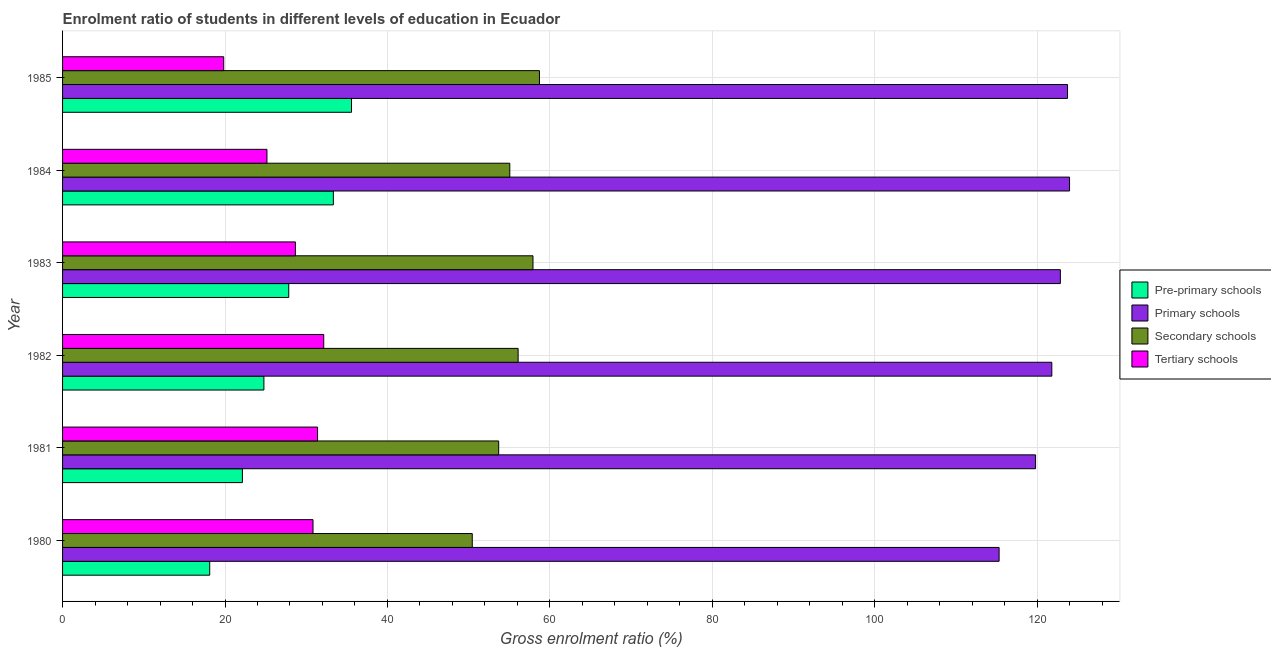How many different coloured bars are there?
Offer a very short reply. 4. Are the number of bars per tick equal to the number of legend labels?
Offer a very short reply. Yes. In how many cases, is the number of bars for a given year not equal to the number of legend labels?
Keep it short and to the point. 0. What is the gross enrolment ratio in tertiary schools in 1980?
Keep it short and to the point. 30.83. Across all years, what is the maximum gross enrolment ratio in primary schools?
Offer a very short reply. 123.98. Across all years, what is the minimum gross enrolment ratio in primary schools?
Your response must be concise. 115.31. What is the total gross enrolment ratio in secondary schools in the graph?
Keep it short and to the point. 331.92. What is the difference between the gross enrolment ratio in secondary schools in 1980 and that in 1985?
Your answer should be compact. -8.27. What is the difference between the gross enrolment ratio in tertiary schools in 1980 and the gross enrolment ratio in secondary schools in 1981?
Give a very brief answer. -22.86. What is the average gross enrolment ratio in tertiary schools per year?
Keep it short and to the point. 28.01. In the year 1983, what is the difference between the gross enrolment ratio in tertiary schools and gross enrolment ratio in pre-primary schools?
Make the answer very short. 0.82. What is the ratio of the gross enrolment ratio in secondary schools in 1980 to that in 1981?
Give a very brief answer. 0.94. What is the difference between the highest and the second highest gross enrolment ratio in primary schools?
Give a very brief answer. 0.25. What is the difference between the highest and the lowest gross enrolment ratio in secondary schools?
Provide a short and direct response. 8.27. What does the 3rd bar from the top in 1980 represents?
Your answer should be very brief. Primary schools. What does the 3rd bar from the bottom in 1982 represents?
Offer a terse response. Secondary schools. Is it the case that in every year, the sum of the gross enrolment ratio in pre-primary schools and gross enrolment ratio in primary schools is greater than the gross enrolment ratio in secondary schools?
Provide a short and direct response. Yes. How many bars are there?
Your answer should be compact. 24. Are all the bars in the graph horizontal?
Offer a terse response. Yes. How many years are there in the graph?
Your answer should be very brief. 6. What is the difference between two consecutive major ticks on the X-axis?
Provide a short and direct response. 20. Does the graph contain any zero values?
Offer a very short reply. No. How many legend labels are there?
Provide a short and direct response. 4. What is the title of the graph?
Make the answer very short. Enrolment ratio of students in different levels of education in Ecuador. What is the label or title of the X-axis?
Offer a very short reply. Gross enrolment ratio (%). What is the Gross enrolment ratio (%) in Pre-primary schools in 1980?
Provide a short and direct response. 18.12. What is the Gross enrolment ratio (%) in Primary schools in 1980?
Offer a terse response. 115.31. What is the Gross enrolment ratio (%) in Secondary schools in 1980?
Your answer should be very brief. 50.44. What is the Gross enrolment ratio (%) in Tertiary schools in 1980?
Give a very brief answer. 30.83. What is the Gross enrolment ratio (%) in Pre-primary schools in 1981?
Offer a very short reply. 22.14. What is the Gross enrolment ratio (%) of Primary schools in 1981?
Your answer should be very brief. 119.79. What is the Gross enrolment ratio (%) in Secondary schools in 1981?
Provide a succinct answer. 53.7. What is the Gross enrolment ratio (%) of Tertiary schools in 1981?
Provide a succinct answer. 31.4. What is the Gross enrolment ratio (%) in Pre-primary schools in 1982?
Keep it short and to the point. 24.79. What is the Gross enrolment ratio (%) of Primary schools in 1982?
Make the answer very short. 121.79. What is the Gross enrolment ratio (%) of Secondary schools in 1982?
Offer a very short reply. 56.09. What is the Gross enrolment ratio (%) in Tertiary schools in 1982?
Keep it short and to the point. 32.16. What is the Gross enrolment ratio (%) in Pre-primary schools in 1983?
Your response must be concise. 27.85. What is the Gross enrolment ratio (%) of Primary schools in 1983?
Ensure brevity in your answer.  122.85. What is the Gross enrolment ratio (%) of Secondary schools in 1983?
Offer a terse response. 57.92. What is the Gross enrolment ratio (%) in Tertiary schools in 1983?
Your answer should be compact. 28.67. What is the Gross enrolment ratio (%) of Pre-primary schools in 1984?
Offer a terse response. 33.34. What is the Gross enrolment ratio (%) of Primary schools in 1984?
Your answer should be compact. 123.98. What is the Gross enrolment ratio (%) in Secondary schools in 1984?
Give a very brief answer. 55.06. What is the Gross enrolment ratio (%) of Tertiary schools in 1984?
Keep it short and to the point. 25.16. What is the Gross enrolment ratio (%) in Pre-primary schools in 1985?
Your response must be concise. 35.57. What is the Gross enrolment ratio (%) in Primary schools in 1985?
Give a very brief answer. 123.73. What is the Gross enrolment ratio (%) in Secondary schools in 1985?
Provide a succinct answer. 58.71. What is the Gross enrolment ratio (%) in Tertiary schools in 1985?
Make the answer very short. 19.84. Across all years, what is the maximum Gross enrolment ratio (%) of Pre-primary schools?
Provide a short and direct response. 35.57. Across all years, what is the maximum Gross enrolment ratio (%) of Primary schools?
Make the answer very short. 123.98. Across all years, what is the maximum Gross enrolment ratio (%) of Secondary schools?
Give a very brief answer. 58.71. Across all years, what is the maximum Gross enrolment ratio (%) in Tertiary schools?
Offer a very short reply. 32.16. Across all years, what is the minimum Gross enrolment ratio (%) in Pre-primary schools?
Give a very brief answer. 18.12. Across all years, what is the minimum Gross enrolment ratio (%) of Primary schools?
Your answer should be very brief. 115.31. Across all years, what is the minimum Gross enrolment ratio (%) in Secondary schools?
Your answer should be compact. 50.44. Across all years, what is the minimum Gross enrolment ratio (%) of Tertiary schools?
Keep it short and to the point. 19.84. What is the total Gross enrolment ratio (%) in Pre-primary schools in the graph?
Your response must be concise. 161.81. What is the total Gross enrolment ratio (%) in Primary schools in the graph?
Provide a short and direct response. 727.45. What is the total Gross enrolment ratio (%) of Secondary schools in the graph?
Offer a very short reply. 331.92. What is the total Gross enrolment ratio (%) of Tertiary schools in the graph?
Your answer should be very brief. 168.05. What is the difference between the Gross enrolment ratio (%) in Pre-primary schools in 1980 and that in 1981?
Your answer should be compact. -4.03. What is the difference between the Gross enrolment ratio (%) of Primary schools in 1980 and that in 1981?
Your response must be concise. -4.49. What is the difference between the Gross enrolment ratio (%) in Secondary schools in 1980 and that in 1981?
Ensure brevity in your answer.  -3.25. What is the difference between the Gross enrolment ratio (%) in Tertiary schools in 1980 and that in 1981?
Make the answer very short. -0.56. What is the difference between the Gross enrolment ratio (%) of Pre-primary schools in 1980 and that in 1982?
Your answer should be very brief. -6.67. What is the difference between the Gross enrolment ratio (%) in Primary schools in 1980 and that in 1982?
Provide a succinct answer. -6.49. What is the difference between the Gross enrolment ratio (%) of Secondary schools in 1980 and that in 1982?
Offer a terse response. -5.65. What is the difference between the Gross enrolment ratio (%) of Tertiary schools in 1980 and that in 1982?
Your answer should be compact. -1.32. What is the difference between the Gross enrolment ratio (%) of Pre-primary schools in 1980 and that in 1983?
Ensure brevity in your answer.  -9.73. What is the difference between the Gross enrolment ratio (%) of Primary schools in 1980 and that in 1983?
Your response must be concise. -7.54. What is the difference between the Gross enrolment ratio (%) in Secondary schools in 1980 and that in 1983?
Make the answer very short. -7.48. What is the difference between the Gross enrolment ratio (%) in Tertiary schools in 1980 and that in 1983?
Your response must be concise. 2.17. What is the difference between the Gross enrolment ratio (%) in Pre-primary schools in 1980 and that in 1984?
Offer a terse response. -15.22. What is the difference between the Gross enrolment ratio (%) of Primary schools in 1980 and that in 1984?
Offer a terse response. -8.67. What is the difference between the Gross enrolment ratio (%) of Secondary schools in 1980 and that in 1984?
Provide a succinct answer. -4.62. What is the difference between the Gross enrolment ratio (%) of Tertiary schools in 1980 and that in 1984?
Your answer should be compact. 5.67. What is the difference between the Gross enrolment ratio (%) in Pre-primary schools in 1980 and that in 1985?
Make the answer very short. -17.46. What is the difference between the Gross enrolment ratio (%) of Primary schools in 1980 and that in 1985?
Make the answer very short. -8.42. What is the difference between the Gross enrolment ratio (%) of Secondary schools in 1980 and that in 1985?
Provide a succinct answer. -8.27. What is the difference between the Gross enrolment ratio (%) in Tertiary schools in 1980 and that in 1985?
Make the answer very short. 11. What is the difference between the Gross enrolment ratio (%) in Pre-primary schools in 1981 and that in 1982?
Offer a very short reply. -2.65. What is the difference between the Gross enrolment ratio (%) in Primary schools in 1981 and that in 1982?
Your answer should be compact. -2. What is the difference between the Gross enrolment ratio (%) of Secondary schools in 1981 and that in 1982?
Provide a succinct answer. -2.39. What is the difference between the Gross enrolment ratio (%) in Tertiary schools in 1981 and that in 1982?
Your answer should be very brief. -0.76. What is the difference between the Gross enrolment ratio (%) in Pre-primary schools in 1981 and that in 1983?
Provide a short and direct response. -5.7. What is the difference between the Gross enrolment ratio (%) in Primary schools in 1981 and that in 1983?
Ensure brevity in your answer.  -3.05. What is the difference between the Gross enrolment ratio (%) in Secondary schools in 1981 and that in 1983?
Ensure brevity in your answer.  -4.22. What is the difference between the Gross enrolment ratio (%) in Tertiary schools in 1981 and that in 1983?
Ensure brevity in your answer.  2.73. What is the difference between the Gross enrolment ratio (%) of Pre-primary schools in 1981 and that in 1984?
Your answer should be compact. -11.2. What is the difference between the Gross enrolment ratio (%) of Primary schools in 1981 and that in 1984?
Your answer should be compact. -4.19. What is the difference between the Gross enrolment ratio (%) of Secondary schools in 1981 and that in 1984?
Your response must be concise. -1.37. What is the difference between the Gross enrolment ratio (%) of Tertiary schools in 1981 and that in 1984?
Give a very brief answer. 6.23. What is the difference between the Gross enrolment ratio (%) in Pre-primary schools in 1981 and that in 1985?
Offer a very short reply. -13.43. What is the difference between the Gross enrolment ratio (%) of Primary schools in 1981 and that in 1985?
Keep it short and to the point. -3.94. What is the difference between the Gross enrolment ratio (%) of Secondary schools in 1981 and that in 1985?
Give a very brief answer. -5.02. What is the difference between the Gross enrolment ratio (%) in Tertiary schools in 1981 and that in 1985?
Your answer should be compact. 11.56. What is the difference between the Gross enrolment ratio (%) in Pre-primary schools in 1982 and that in 1983?
Offer a terse response. -3.06. What is the difference between the Gross enrolment ratio (%) of Primary schools in 1982 and that in 1983?
Provide a short and direct response. -1.05. What is the difference between the Gross enrolment ratio (%) of Secondary schools in 1982 and that in 1983?
Ensure brevity in your answer.  -1.83. What is the difference between the Gross enrolment ratio (%) in Tertiary schools in 1982 and that in 1983?
Your response must be concise. 3.49. What is the difference between the Gross enrolment ratio (%) in Pre-primary schools in 1982 and that in 1984?
Your answer should be compact. -8.55. What is the difference between the Gross enrolment ratio (%) of Primary schools in 1982 and that in 1984?
Your response must be concise. -2.18. What is the difference between the Gross enrolment ratio (%) in Secondary schools in 1982 and that in 1984?
Your response must be concise. 1.03. What is the difference between the Gross enrolment ratio (%) in Tertiary schools in 1982 and that in 1984?
Your answer should be very brief. 6.99. What is the difference between the Gross enrolment ratio (%) of Pre-primary schools in 1982 and that in 1985?
Your answer should be compact. -10.78. What is the difference between the Gross enrolment ratio (%) in Primary schools in 1982 and that in 1985?
Your answer should be very brief. -1.94. What is the difference between the Gross enrolment ratio (%) of Secondary schools in 1982 and that in 1985?
Provide a succinct answer. -2.63. What is the difference between the Gross enrolment ratio (%) of Tertiary schools in 1982 and that in 1985?
Your response must be concise. 12.32. What is the difference between the Gross enrolment ratio (%) in Pre-primary schools in 1983 and that in 1984?
Keep it short and to the point. -5.49. What is the difference between the Gross enrolment ratio (%) in Primary schools in 1983 and that in 1984?
Provide a short and direct response. -1.13. What is the difference between the Gross enrolment ratio (%) in Secondary schools in 1983 and that in 1984?
Your response must be concise. 2.85. What is the difference between the Gross enrolment ratio (%) of Tertiary schools in 1983 and that in 1984?
Give a very brief answer. 3.5. What is the difference between the Gross enrolment ratio (%) in Pre-primary schools in 1983 and that in 1985?
Ensure brevity in your answer.  -7.73. What is the difference between the Gross enrolment ratio (%) in Primary schools in 1983 and that in 1985?
Offer a very short reply. -0.88. What is the difference between the Gross enrolment ratio (%) in Secondary schools in 1983 and that in 1985?
Offer a very short reply. -0.8. What is the difference between the Gross enrolment ratio (%) of Tertiary schools in 1983 and that in 1985?
Make the answer very short. 8.83. What is the difference between the Gross enrolment ratio (%) of Pre-primary schools in 1984 and that in 1985?
Make the answer very short. -2.23. What is the difference between the Gross enrolment ratio (%) in Primary schools in 1984 and that in 1985?
Offer a terse response. 0.25. What is the difference between the Gross enrolment ratio (%) of Secondary schools in 1984 and that in 1985?
Make the answer very short. -3.65. What is the difference between the Gross enrolment ratio (%) of Tertiary schools in 1984 and that in 1985?
Keep it short and to the point. 5.33. What is the difference between the Gross enrolment ratio (%) in Pre-primary schools in 1980 and the Gross enrolment ratio (%) in Primary schools in 1981?
Your answer should be very brief. -101.68. What is the difference between the Gross enrolment ratio (%) in Pre-primary schools in 1980 and the Gross enrolment ratio (%) in Secondary schools in 1981?
Provide a short and direct response. -35.58. What is the difference between the Gross enrolment ratio (%) of Pre-primary schools in 1980 and the Gross enrolment ratio (%) of Tertiary schools in 1981?
Provide a short and direct response. -13.28. What is the difference between the Gross enrolment ratio (%) of Primary schools in 1980 and the Gross enrolment ratio (%) of Secondary schools in 1981?
Give a very brief answer. 61.61. What is the difference between the Gross enrolment ratio (%) of Primary schools in 1980 and the Gross enrolment ratio (%) of Tertiary schools in 1981?
Give a very brief answer. 83.91. What is the difference between the Gross enrolment ratio (%) in Secondary schools in 1980 and the Gross enrolment ratio (%) in Tertiary schools in 1981?
Ensure brevity in your answer.  19.05. What is the difference between the Gross enrolment ratio (%) of Pre-primary schools in 1980 and the Gross enrolment ratio (%) of Primary schools in 1982?
Keep it short and to the point. -103.68. What is the difference between the Gross enrolment ratio (%) of Pre-primary schools in 1980 and the Gross enrolment ratio (%) of Secondary schools in 1982?
Your answer should be compact. -37.97. What is the difference between the Gross enrolment ratio (%) of Pre-primary schools in 1980 and the Gross enrolment ratio (%) of Tertiary schools in 1982?
Your answer should be compact. -14.04. What is the difference between the Gross enrolment ratio (%) in Primary schools in 1980 and the Gross enrolment ratio (%) in Secondary schools in 1982?
Make the answer very short. 59.22. What is the difference between the Gross enrolment ratio (%) in Primary schools in 1980 and the Gross enrolment ratio (%) in Tertiary schools in 1982?
Provide a succinct answer. 83.15. What is the difference between the Gross enrolment ratio (%) of Secondary schools in 1980 and the Gross enrolment ratio (%) of Tertiary schools in 1982?
Offer a terse response. 18.29. What is the difference between the Gross enrolment ratio (%) in Pre-primary schools in 1980 and the Gross enrolment ratio (%) in Primary schools in 1983?
Make the answer very short. -104.73. What is the difference between the Gross enrolment ratio (%) of Pre-primary schools in 1980 and the Gross enrolment ratio (%) of Secondary schools in 1983?
Your response must be concise. -39.8. What is the difference between the Gross enrolment ratio (%) of Pre-primary schools in 1980 and the Gross enrolment ratio (%) of Tertiary schools in 1983?
Offer a terse response. -10.55. What is the difference between the Gross enrolment ratio (%) of Primary schools in 1980 and the Gross enrolment ratio (%) of Secondary schools in 1983?
Offer a terse response. 57.39. What is the difference between the Gross enrolment ratio (%) in Primary schools in 1980 and the Gross enrolment ratio (%) in Tertiary schools in 1983?
Give a very brief answer. 86.64. What is the difference between the Gross enrolment ratio (%) of Secondary schools in 1980 and the Gross enrolment ratio (%) of Tertiary schools in 1983?
Provide a short and direct response. 21.77. What is the difference between the Gross enrolment ratio (%) in Pre-primary schools in 1980 and the Gross enrolment ratio (%) in Primary schools in 1984?
Offer a terse response. -105.86. What is the difference between the Gross enrolment ratio (%) in Pre-primary schools in 1980 and the Gross enrolment ratio (%) in Secondary schools in 1984?
Provide a succinct answer. -36.95. What is the difference between the Gross enrolment ratio (%) in Pre-primary schools in 1980 and the Gross enrolment ratio (%) in Tertiary schools in 1984?
Offer a very short reply. -7.05. What is the difference between the Gross enrolment ratio (%) in Primary schools in 1980 and the Gross enrolment ratio (%) in Secondary schools in 1984?
Make the answer very short. 60.24. What is the difference between the Gross enrolment ratio (%) in Primary schools in 1980 and the Gross enrolment ratio (%) in Tertiary schools in 1984?
Offer a very short reply. 90.14. What is the difference between the Gross enrolment ratio (%) in Secondary schools in 1980 and the Gross enrolment ratio (%) in Tertiary schools in 1984?
Your answer should be very brief. 25.28. What is the difference between the Gross enrolment ratio (%) of Pre-primary schools in 1980 and the Gross enrolment ratio (%) of Primary schools in 1985?
Your answer should be very brief. -105.61. What is the difference between the Gross enrolment ratio (%) in Pre-primary schools in 1980 and the Gross enrolment ratio (%) in Secondary schools in 1985?
Keep it short and to the point. -40.6. What is the difference between the Gross enrolment ratio (%) of Pre-primary schools in 1980 and the Gross enrolment ratio (%) of Tertiary schools in 1985?
Keep it short and to the point. -1.72. What is the difference between the Gross enrolment ratio (%) in Primary schools in 1980 and the Gross enrolment ratio (%) in Secondary schools in 1985?
Provide a short and direct response. 56.59. What is the difference between the Gross enrolment ratio (%) of Primary schools in 1980 and the Gross enrolment ratio (%) of Tertiary schools in 1985?
Your answer should be compact. 95.47. What is the difference between the Gross enrolment ratio (%) in Secondary schools in 1980 and the Gross enrolment ratio (%) in Tertiary schools in 1985?
Offer a very short reply. 30.6. What is the difference between the Gross enrolment ratio (%) of Pre-primary schools in 1981 and the Gross enrolment ratio (%) of Primary schools in 1982?
Your answer should be compact. -99.65. What is the difference between the Gross enrolment ratio (%) in Pre-primary schools in 1981 and the Gross enrolment ratio (%) in Secondary schools in 1982?
Provide a short and direct response. -33.95. What is the difference between the Gross enrolment ratio (%) in Pre-primary schools in 1981 and the Gross enrolment ratio (%) in Tertiary schools in 1982?
Your answer should be very brief. -10.01. What is the difference between the Gross enrolment ratio (%) of Primary schools in 1981 and the Gross enrolment ratio (%) of Secondary schools in 1982?
Provide a short and direct response. 63.71. What is the difference between the Gross enrolment ratio (%) in Primary schools in 1981 and the Gross enrolment ratio (%) in Tertiary schools in 1982?
Offer a very short reply. 87.64. What is the difference between the Gross enrolment ratio (%) in Secondary schools in 1981 and the Gross enrolment ratio (%) in Tertiary schools in 1982?
Offer a terse response. 21.54. What is the difference between the Gross enrolment ratio (%) of Pre-primary schools in 1981 and the Gross enrolment ratio (%) of Primary schools in 1983?
Your answer should be very brief. -100.7. What is the difference between the Gross enrolment ratio (%) in Pre-primary schools in 1981 and the Gross enrolment ratio (%) in Secondary schools in 1983?
Make the answer very short. -35.77. What is the difference between the Gross enrolment ratio (%) of Pre-primary schools in 1981 and the Gross enrolment ratio (%) of Tertiary schools in 1983?
Your answer should be very brief. -6.52. What is the difference between the Gross enrolment ratio (%) in Primary schools in 1981 and the Gross enrolment ratio (%) in Secondary schools in 1983?
Your response must be concise. 61.88. What is the difference between the Gross enrolment ratio (%) of Primary schools in 1981 and the Gross enrolment ratio (%) of Tertiary schools in 1983?
Your answer should be very brief. 91.13. What is the difference between the Gross enrolment ratio (%) of Secondary schools in 1981 and the Gross enrolment ratio (%) of Tertiary schools in 1983?
Offer a very short reply. 25.03. What is the difference between the Gross enrolment ratio (%) of Pre-primary schools in 1981 and the Gross enrolment ratio (%) of Primary schools in 1984?
Give a very brief answer. -101.84. What is the difference between the Gross enrolment ratio (%) of Pre-primary schools in 1981 and the Gross enrolment ratio (%) of Secondary schools in 1984?
Your answer should be very brief. -32.92. What is the difference between the Gross enrolment ratio (%) in Pre-primary schools in 1981 and the Gross enrolment ratio (%) in Tertiary schools in 1984?
Keep it short and to the point. -3.02. What is the difference between the Gross enrolment ratio (%) of Primary schools in 1981 and the Gross enrolment ratio (%) of Secondary schools in 1984?
Give a very brief answer. 64.73. What is the difference between the Gross enrolment ratio (%) in Primary schools in 1981 and the Gross enrolment ratio (%) in Tertiary schools in 1984?
Give a very brief answer. 94.63. What is the difference between the Gross enrolment ratio (%) in Secondary schools in 1981 and the Gross enrolment ratio (%) in Tertiary schools in 1984?
Your response must be concise. 28.53. What is the difference between the Gross enrolment ratio (%) in Pre-primary schools in 1981 and the Gross enrolment ratio (%) in Primary schools in 1985?
Offer a terse response. -101.59. What is the difference between the Gross enrolment ratio (%) of Pre-primary schools in 1981 and the Gross enrolment ratio (%) of Secondary schools in 1985?
Offer a terse response. -36.57. What is the difference between the Gross enrolment ratio (%) in Pre-primary schools in 1981 and the Gross enrolment ratio (%) in Tertiary schools in 1985?
Offer a very short reply. 2.3. What is the difference between the Gross enrolment ratio (%) in Primary schools in 1981 and the Gross enrolment ratio (%) in Secondary schools in 1985?
Make the answer very short. 61.08. What is the difference between the Gross enrolment ratio (%) in Primary schools in 1981 and the Gross enrolment ratio (%) in Tertiary schools in 1985?
Provide a succinct answer. 99.96. What is the difference between the Gross enrolment ratio (%) in Secondary schools in 1981 and the Gross enrolment ratio (%) in Tertiary schools in 1985?
Give a very brief answer. 33.86. What is the difference between the Gross enrolment ratio (%) of Pre-primary schools in 1982 and the Gross enrolment ratio (%) of Primary schools in 1983?
Keep it short and to the point. -98.06. What is the difference between the Gross enrolment ratio (%) in Pre-primary schools in 1982 and the Gross enrolment ratio (%) in Secondary schools in 1983?
Ensure brevity in your answer.  -33.13. What is the difference between the Gross enrolment ratio (%) in Pre-primary schools in 1982 and the Gross enrolment ratio (%) in Tertiary schools in 1983?
Make the answer very short. -3.88. What is the difference between the Gross enrolment ratio (%) of Primary schools in 1982 and the Gross enrolment ratio (%) of Secondary schools in 1983?
Offer a terse response. 63.88. What is the difference between the Gross enrolment ratio (%) of Primary schools in 1982 and the Gross enrolment ratio (%) of Tertiary schools in 1983?
Ensure brevity in your answer.  93.13. What is the difference between the Gross enrolment ratio (%) of Secondary schools in 1982 and the Gross enrolment ratio (%) of Tertiary schools in 1983?
Provide a succinct answer. 27.42. What is the difference between the Gross enrolment ratio (%) of Pre-primary schools in 1982 and the Gross enrolment ratio (%) of Primary schools in 1984?
Provide a succinct answer. -99.19. What is the difference between the Gross enrolment ratio (%) in Pre-primary schools in 1982 and the Gross enrolment ratio (%) in Secondary schools in 1984?
Your answer should be very brief. -30.27. What is the difference between the Gross enrolment ratio (%) of Pre-primary schools in 1982 and the Gross enrolment ratio (%) of Tertiary schools in 1984?
Give a very brief answer. -0.37. What is the difference between the Gross enrolment ratio (%) of Primary schools in 1982 and the Gross enrolment ratio (%) of Secondary schools in 1984?
Your answer should be very brief. 66.73. What is the difference between the Gross enrolment ratio (%) of Primary schools in 1982 and the Gross enrolment ratio (%) of Tertiary schools in 1984?
Provide a succinct answer. 96.63. What is the difference between the Gross enrolment ratio (%) of Secondary schools in 1982 and the Gross enrolment ratio (%) of Tertiary schools in 1984?
Provide a short and direct response. 30.93. What is the difference between the Gross enrolment ratio (%) of Pre-primary schools in 1982 and the Gross enrolment ratio (%) of Primary schools in 1985?
Provide a succinct answer. -98.94. What is the difference between the Gross enrolment ratio (%) in Pre-primary schools in 1982 and the Gross enrolment ratio (%) in Secondary schools in 1985?
Ensure brevity in your answer.  -33.92. What is the difference between the Gross enrolment ratio (%) in Pre-primary schools in 1982 and the Gross enrolment ratio (%) in Tertiary schools in 1985?
Make the answer very short. 4.95. What is the difference between the Gross enrolment ratio (%) in Primary schools in 1982 and the Gross enrolment ratio (%) in Secondary schools in 1985?
Your response must be concise. 63.08. What is the difference between the Gross enrolment ratio (%) of Primary schools in 1982 and the Gross enrolment ratio (%) of Tertiary schools in 1985?
Your answer should be compact. 101.96. What is the difference between the Gross enrolment ratio (%) of Secondary schools in 1982 and the Gross enrolment ratio (%) of Tertiary schools in 1985?
Your response must be concise. 36.25. What is the difference between the Gross enrolment ratio (%) of Pre-primary schools in 1983 and the Gross enrolment ratio (%) of Primary schools in 1984?
Your response must be concise. -96.13. What is the difference between the Gross enrolment ratio (%) of Pre-primary schools in 1983 and the Gross enrolment ratio (%) of Secondary schools in 1984?
Your answer should be compact. -27.21. What is the difference between the Gross enrolment ratio (%) in Pre-primary schools in 1983 and the Gross enrolment ratio (%) in Tertiary schools in 1984?
Give a very brief answer. 2.68. What is the difference between the Gross enrolment ratio (%) of Primary schools in 1983 and the Gross enrolment ratio (%) of Secondary schools in 1984?
Keep it short and to the point. 67.79. What is the difference between the Gross enrolment ratio (%) in Primary schools in 1983 and the Gross enrolment ratio (%) in Tertiary schools in 1984?
Ensure brevity in your answer.  97.68. What is the difference between the Gross enrolment ratio (%) in Secondary schools in 1983 and the Gross enrolment ratio (%) in Tertiary schools in 1984?
Ensure brevity in your answer.  32.75. What is the difference between the Gross enrolment ratio (%) of Pre-primary schools in 1983 and the Gross enrolment ratio (%) of Primary schools in 1985?
Provide a short and direct response. -95.88. What is the difference between the Gross enrolment ratio (%) in Pre-primary schools in 1983 and the Gross enrolment ratio (%) in Secondary schools in 1985?
Your response must be concise. -30.87. What is the difference between the Gross enrolment ratio (%) in Pre-primary schools in 1983 and the Gross enrolment ratio (%) in Tertiary schools in 1985?
Your response must be concise. 8.01. What is the difference between the Gross enrolment ratio (%) in Primary schools in 1983 and the Gross enrolment ratio (%) in Secondary schools in 1985?
Ensure brevity in your answer.  64.13. What is the difference between the Gross enrolment ratio (%) of Primary schools in 1983 and the Gross enrolment ratio (%) of Tertiary schools in 1985?
Ensure brevity in your answer.  103.01. What is the difference between the Gross enrolment ratio (%) of Secondary schools in 1983 and the Gross enrolment ratio (%) of Tertiary schools in 1985?
Ensure brevity in your answer.  38.08. What is the difference between the Gross enrolment ratio (%) of Pre-primary schools in 1984 and the Gross enrolment ratio (%) of Primary schools in 1985?
Your response must be concise. -90.39. What is the difference between the Gross enrolment ratio (%) in Pre-primary schools in 1984 and the Gross enrolment ratio (%) in Secondary schools in 1985?
Your answer should be very brief. -25.38. What is the difference between the Gross enrolment ratio (%) of Pre-primary schools in 1984 and the Gross enrolment ratio (%) of Tertiary schools in 1985?
Provide a succinct answer. 13.5. What is the difference between the Gross enrolment ratio (%) in Primary schools in 1984 and the Gross enrolment ratio (%) in Secondary schools in 1985?
Offer a very short reply. 65.26. What is the difference between the Gross enrolment ratio (%) in Primary schools in 1984 and the Gross enrolment ratio (%) in Tertiary schools in 1985?
Offer a very short reply. 104.14. What is the difference between the Gross enrolment ratio (%) of Secondary schools in 1984 and the Gross enrolment ratio (%) of Tertiary schools in 1985?
Ensure brevity in your answer.  35.22. What is the average Gross enrolment ratio (%) in Pre-primary schools per year?
Offer a terse response. 26.97. What is the average Gross enrolment ratio (%) of Primary schools per year?
Offer a very short reply. 121.24. What is the average Gross enrolment ratio (%) in Secondary schools per year?
Your response must be concise. 55.32. What is the average Gross enrolment ratio (%) in Tertiary schools per year?
Your answer should be very brief. 28.01. In the year 1980, what is the difference between the Gross enrolment ratio (%) in Pre-primary schools and Gross enrolment ratio (%) in Primary schools?
Ensure brevity in your answer.  -97.19. In the year 1980, what is the difference between the Gross enrolment ratio (%) in Pre-primary schools and Gross enrolment ratio (%) in Secondary schools?
Offer a very short reply. -32.32. In the year 1980, what is the difference between the Gross enrolment ratio (%) of Pre-primary schools and Gross enrolment ratio (%) of Tertiary schools?
Give a very brief answer. -12.72. In the year 1980, what is the difference between the Gross enrolment ratio (%) of Primary schools and Gross enrolment ratio (%) of Secondary schools?
Your answer should be compact. 64.86. In the year 1980, what is the difference between the Gross enrolment ratio (%) in Primary schools and Gross enrolment ratio (%) in Tertiary schools?
Provide a succinct answer. 84.47. In the year 1980, what is the difference between the Gross enrolment ratio (%) of Secondary schools and Gross enrolment ratio (%) of Tertiary schools?
Provide a short and direct response. 19.61. In the year 1981, what is the difference between the Gross enrolment ratio (%) in Pre-primary schools and Gross enrolment ratio (%) in Primary schools?
Ensure brevity in your answer.  -97.65. In the year 1981, what is the difference between the Gross enrolment ratio (%) in Pre-primary schools and Gross enrolment ratio (%) in Secondary schools?
Offer a very short reply. -31.55. In the year 1981, what is the difference between the Gross enrolment ratio (%) of Pre-primary schools and Gross enrolment ratio (%) of Tertiary schools?
Ensure brevity in your answer.  -9.25. In the year 1981, what is the difference between the Gross enrolment ratio (%) of Primary schools and Gross enrolment ratio (%) of Secondary schools?
Offer a terse response. 66.1. In the year 1981, what is the difference between the Gross enrolment ratio (%) of Primary schools and Gross enrolment ratio (%) of Tertiary schools?
Give a very brief answer. 88.4. In the year 1981, what is the difference between the Gross enrolment ratio (%) in Secondary schools and Gross enrolment ratio (%) in Tertiary schools?
Ensure brevity in your answer.  22.3. In the year 1982, what is the difference between the Gross enrolment ratio (%) of Pre-primary schools and Gross enrolment ratio (%) of Primary schools?
Ensure brevity in your answer.  -97.01. In the year 1982, what is the difference between the Gross enrolment ratio (%) of Pre-primary schools and Gross enrolment ratio (%) of Secondary schools?
Ensure brevity in your answer.  -31.3. In the year 1982, what is the difference between the Gross enrolment ratio (%) of Pre-primary schools and Gross enrolment ratio (%) of Tertiary schools?
Ensure brevity in your answer.  -7.37. In the year 1982, what is the difference between the Gross enrolment ratio (%) in Primary schools and Gross enrolment ratio (%) in Secondary schools?
Offer a very short reply. 65.71. In the year 1982, what is the difference between the Gross enrolment ratio (%) of Primary schools and Gross enrolment ratio (%) of Tertiary schools?
Provide a succinct answer. 89.64. In the year 1982, what is the difference between the Gross enrolment ratio (%) in Secondary schools and Gross enrolment ratio (%) in Tertiary schools?
Offer a very short reply. 23.93. In the year 1983, what is the difference between the Gross enrolment ratio (%) of Pre-primary schools and Gross enrolment ratio (%) of Primary schools?
Offer a very short reply. -95. In the year 1983, what is the difference between the Gross enrolment ratio (%) of Pre-primary schools and Gross enrolment ratio (%) of Secondary schools?
Provide a succinct answer. -30.07. In the year 1983, what is the difference between the Gross enrolment ratio (%) of Pre-primary schools and Gross enrolment ratio (%) of Tertiary schools?
Give a very brief answer. -0.82. In the year 1983, what is the difference between the Gross enrolment ratio (%) of Primary schools and Gross enrolment ratio (%) of Secondary schools?
Provide a succinct answer. 64.93. In the year 1983, what is the difference between the Gross enrolment ratio (%) of Primary schools and Gross enrolment ratio (%) of Tertiary schools?
Offer a terse response. 94.18. In the year 1983, what is the difference between the Gross enrolment ratio (%) of Secondary schools and Gross enrolment ratio (%) of Tertiary schools?
Your answer should be compact. 29.25. In the year 1984, what is the difference between the Gross enrolment ratio (%) of Pre-primary schools and Gross enrolment ratio (%) of Primary schools?
Your answer should be compact. -90.64. In the year 1984, what is the difference between the Gross enrolment ratio (%) in Pre-primary schools and Gross enrolment ratio (%) in Secondary schools?
Your answer should be very brief. -21.72. In the year 1984, what is the difference between the Gross enrolment ratio (%) of Pre-primary schools and Gross enrolment ratio (%) of Tertiary schools?
Keep it short and to the point. 8.18. In the year 1984, what is the difference between the Gross enrolment ratio (%) in Primary schools and Gross enrolment ratio (%) in Secondary schools?
Make the answer very short. 68.92. In the year 1984, what is the difference between the Gross enrolment ratio (%) of Primary schools and Gross enrolment ratio (%) of Tertiary schools?
Ensure brevity in your answer.  98.82. In the year 1984, what is the difference between the Gross enrolment ratio (%) in Secondary schools and Gross enrolment ratio (%) in Tertiary schools?
Your answer should be very brief. 29.9. In the year 1985, what is the difference between the Gross enrolment ratio (%) of Pre-primary schools and Gross enrolment ratio (%) of Primary schools?
Your answer should be very brief. -88.16. In the year 1985, what is the difference between the Gross enrolment ratio (%) of Pre-primary schools and Gross enrolment ratio (%) of Secondary schools?
Offer a very short reply. -23.14. In the year 1985, what is the difference between the Gross enrolment ratio (%) in Pre-primary schools and Gross enrolment ratio (%) in Tertiary schools?
Your response must be concise. 15.73. In the year 1985, what is the difference between the Gross enrolment ratio (%) in Primary schools and Gross enrolment ratio (%) in Secondary schools?
Your answer should be very brief. 65.02. In the year 1985, what is the difference between the Gross enrolment ratio (%) of Primary schools and Gross enrolment ratio (%) of Tertiary schools?
Provide a succinct answer. 103.89. In the year 1985, what is the difference between the Gross enrolment ratio (%) of Secondary schools and Gross enrolment ratio (%) of Tertiary schools?
Your answer should be very brief. 38.88. What is the ratio of the Gross enrolment ratio (%) in Pre-primary schools in 1980 to that in 1981?
Offer a very short reply. 0.82. What is the ratio of the Gross enrolment ratio (%) in Primary schools in 1980 to that in 1981?
Provide a short and direct response. 0.96. What is the ratio of the Gross enrolment ratio (%) in Secondary schools in 1980 to that in 1981?
Your answer should be very brief. 0.94. What is the ratio of the Gross enrolment ratio (%) of Tertiary schools in 1980 to that in 1981?
Your response must be concise. 0.98. What is the ratio of the Gross enrolment ratio (%) of Pre-primary schools in 1980 to that in 1982?
Provide a short and direct response. 0.73. What is the ratio of the Gross enrolment ratio (%) of Primary schools in 1980 to that in 1982?
Your response must be concise. 0.95. What is the ratio of the Gross enrolment ratio (%) in Secondary schools in 1980 to that in 1982?
Make the answer very short. 0.9. What is the ratio of the Gross enrolment ratio (%) of Tertiary schools in 1980 to that in 1982?
Your answer should be compact. 0.96. What is the ratio of the Gross enrolment ratio (%) in Pre-primary schools in 1980 to that in 1983?
Your answer should be very brief. 0.65. What is the ratio of the Gross enrolment ratio (%) in Primary schools in 1980 to that in 1983?
Keep it short and to the point. 0.94. What is the ratio of the Gross enrolment ratio (%) of Secondary schools in 1980 to that in 1983?
Give a very brief answer. 0.87. What is the ratio of the Gross enrolment ratio (%) of Tertiary schools in 1980 to that in 1983?
Your response must be concise. 1.08. What is the ratio of the Gross enrolment ratio (%) of Pre-primary schools in 1980 to that in 1984?
Keep it short and to the point. 0.54. What is the ratio of the Gross enrolment ratio (%) in Secondary schools in 1980 to that in 1984?
Offer a very short reply. 0.92. What is the ratio of the Gross enrolment ratio (%) in Tertiary schools in 1980 to that in 1984?
Your answer should be compact. 1.23. What is the ratio of the Gross enrolment ratio (%) of Pre-primary schools in 1980 to that in 1985?
Offer a terse response. 0.51. What is the ratio of the Gross enrolment ratio (%) in Primary schools in 1980 to that in 1985?
Your answer should be compact. 0.93. What is the ratio of the Gross enrolment ratio (%) in Secondary schools in 1980 to that in 1985?
Your response must be concise. 0.86. What is the ratio of the Gross enrolment ratio (%) of Tertiary schools in 1980 to that in 1985?
Provide a succinct answer. 1.55. What is the ratio of the Gross enrolment ratio (%) of Pre-primary schools in 1981 to that in 1982?
Your answer should be very brief. 0.89. What is the ratio of the Gross enrolment ratio (%) of Primary schools in 1981 to that in 1982?
Your answer should be compact. 0.98. What is the ratio of the Gross enrolment ratio (%) in Secondary schools in 1981 to that in 1982?
Offer a terse response. 0.96. What is the ratio of the Gross enrolment ratio (%) in Tertiary schools in 1981 to that in 1982?
Provide a succinct answer. 0.98. What is the ratio of the Gross enrolment ratio (%) in Pre-primary schools in 1981 to that in 1983?
Keep it short and to the point. 0.8. What is the ratio of the Gross enrolment ratio (%) in Primary schools in 1981 to that in 1983?
Make the answer very short. 0.98. What is the ratio of the Gross enrolment ratio (%) in Secondary schools in 1981 to that in 1983?
Provide a succinct answer. 0.93. What is the ratio of the Gross enrolment ratio (%) in Tertiary schools in 1981 to that in 1983?
Ensure brevity in your answer.  1.1. What is the ratio of the Gross enrolment ratio (%) of Pre-primary schools in 1981 to that in 1984?
Ensure brevity in your answer.  0.66. What is the ratio of the Gross enrolment ratio (%) of Primary schools in 1981 to that in 1984?
Make the answer very short. 0.97. What is the ratio of the Gross enrolment ratio (%) of Secondary schools in 1981 to that in 1984?
Give a very brief answer. 0.98. What is the ratio of the Gross enrolment ratio (%) in Tertiary schools in 1981 to that in 1984?
Keep it short and to the point. 1.25. What is the ratio of the Gross enrolment ratio (%) of Pre-primary schools in 1981 to that in 1985?
Ensure brevity in your answer.  0.62. What is the ratio of the Gross enrolment ratio (%) in Primary schools in 1981 to that in 1985?
Make the answer very short. 0.97. What is the ratio of the Gross enrolment ratio (%) in Secondary schools in 1981 to that in 1985?
Your answer should be very brief. 0.91. What is the ratio of the Gross enrolment ratio (%) in Tertiary schools in 1981 to that in 1985?
Offer a terse response. 1.58. What is the ratio of the Gross enrolment ratio (%) in Pre-primary schools in 1982 to that in 1983?
Offer a terse response. 0.89. What is the ratio of the Gross enrolment ratio (%) of Secondary schools in 1982 to that in 1983?
Your answer should be compact. 0.97. What is the ratio of the Gross enrolment ratio (%) in Tertiary schools in 1982 to that in 1983?
Give a very brief answer. 1.12. What is the ratio of the Gross enrolment ratio (%) in Pre-primary schools in 1982 to that in 1984?
Provide a short and direct response. 0.74. What is the ratio of the Gross enrolment ratio (%) in Primary schools in 1982 to that in 1984?
Ensure brevity in your answer.  0.98. What is the ratio of the Gross enrolment ratio (%) in Secondary schools in 1982 to that in 1984?
Offer a very short reply. 1.02. What is the ratio of the Gross enrolment ratio (%) of Tertiary schools in 1982 to that in 1984?
Your answer should be compact. 1.28. What is the ratio of the Gross enrolment ratio (%) of Pre-primary schools in 1982 to that in 1985?
Provide a succinct answer. 0.7. What is the ratio of the Gross enrolment ratio (%) of Primary schools in 1982 to that in 1985?
Keep it short and to the point. 0.98. What is the ratio of the Gross enrolment ratio (%) of Secondary schools in 1982 to that in 1985?
Your response must be concise. 0.96. What is the ratio of the Gross enrolment ratio (%) of Tertiary schools in 1982 to that in 1985?
Offer a terse response. 1.62. What is the ratio of the Gross enrolment ratio (%) of Pre-primary schools in 1983 to that in 1984?
Provide a succinct answer. 0.84. What is the ratio of the Gross enrolment ratio (%) in Primary schools in 1983 to that in 1984?
Keep it short and to the point. 0.99. What is the ratio of the Gross enrolment ratio (%) in Secondary schools in 1983 to that in 1984?
Ensure brevity in your answer.  1.05. What is the ratio of the Gross enrolment ratio (%) in Tertiary schools in 1983 to that in 1984?
Provide a short and direct response. 1.14. What is the ratio of the Gross enrolment ratio (%) of Pre-primary schools in 1983 to that in 1985?
Offer a terse response. 0.78. What is the ratio of the Gross enrolment ratio (%) in Secondary schools in 1983 to that in 1985?
Provide a succinct answer. 0.99. What is the ratio of the Gross enrolment ratio (%) in Tertiary schools in 1983 to that in 1985?
Offer a terse response. 1.45. What is the ratio of the Gross enrolment ratio (%) of Pre-primary schools in 1984 to that in 1985?
Your response must be concise. 0.94. What is the ratio of the Gross enrolment ratio (%) of Secondary schools in 1984 to that in 1985?
Offer a terse response. 0.94. What is the ratio of the Gross enrolment ratio (%) of Tertiary schools in 1984 to that in 1985?
Offer a terse response. 1.27. What is the difference between the highest and the second highest Gross enrolment ratio (%) of Pre-primary schools?
Make the answer very short. 2.23. What is the difference between the highest and the second highest Gross enrolment ratio (%) of Primary schools?
Provide a short and direct response. 0.25. What is the difference between the highest and the second highest Gross enrolment ratio (%) of Secondary schools?
Offer a terse response. 0.8. What is the difference between the highest and the second highest Gross enrolment ratio (%) in Tertiary schools?
Give a very brief answer. 0.76. What is the difference between the highest and the lowest Gross enrolment ratio (%) in Pre-primary schools?
Offer a very short reply. 17.46. What is the difference between the highest and the lowest Gross enrolment ratio (%) in Primary schools?
Provide a short and direct response. 8.67. What is the difference between the highest and the lowest Gross enrolment ratio (%) in Secondary schools?
Keep it short and to the point. 8.27. What is the difference between the highest and the lowest Gross enrolment ratio (%) in Tertiary schools?
Your answer should be very brief. 12.32. 